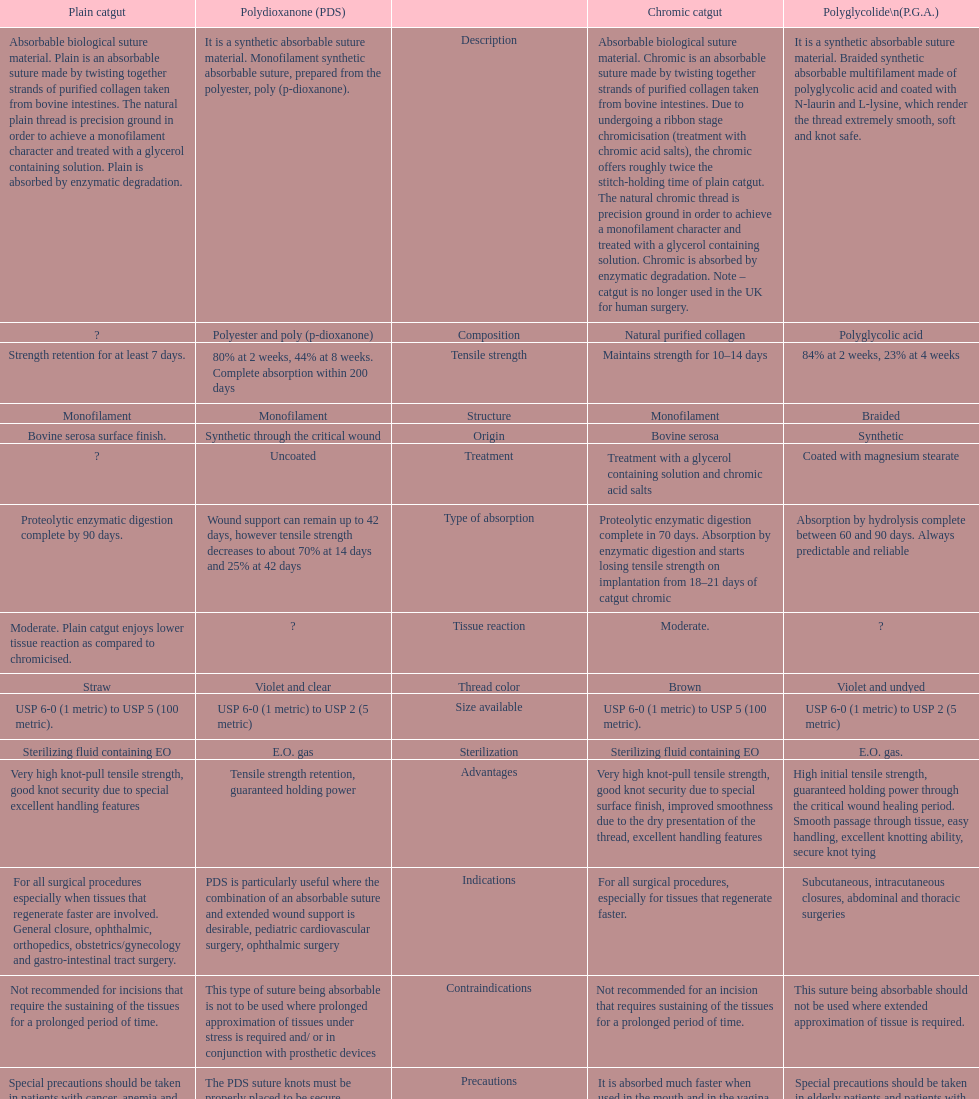How much time does a chromic catgut sustain its strength for? 10-14 days. 